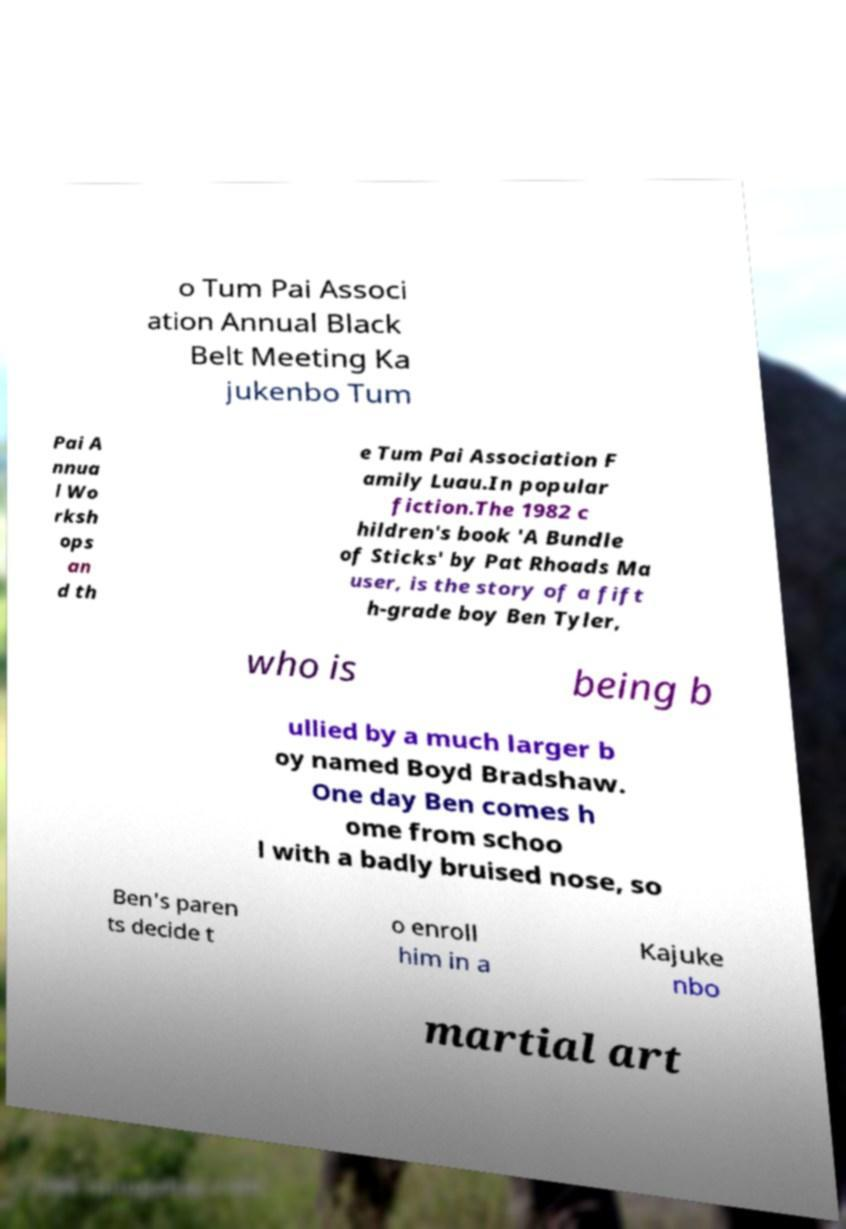Please read and relay the text visible in this image. What does it say? o Tum Pai Associ ation Annual Black Belt Meeting Ka jukenbo Tum Pai A nnua l Wo rksh ops an d th e Tum Pai Association F amily Luau.In popular fiction.The 1982 c hildren's book 'A Bundle of Sticks' by Pat Rhoads Ma user, is the story of a fift h-grade boy Ben Tyler, who is being b ullied by a much larger b oy named Boyd Bradshaw. One day Ben comes h ome from schoo l with a badly bruised nose, so Ben's paren ts decide t o enroll him in a Kajuke nbo martial art 